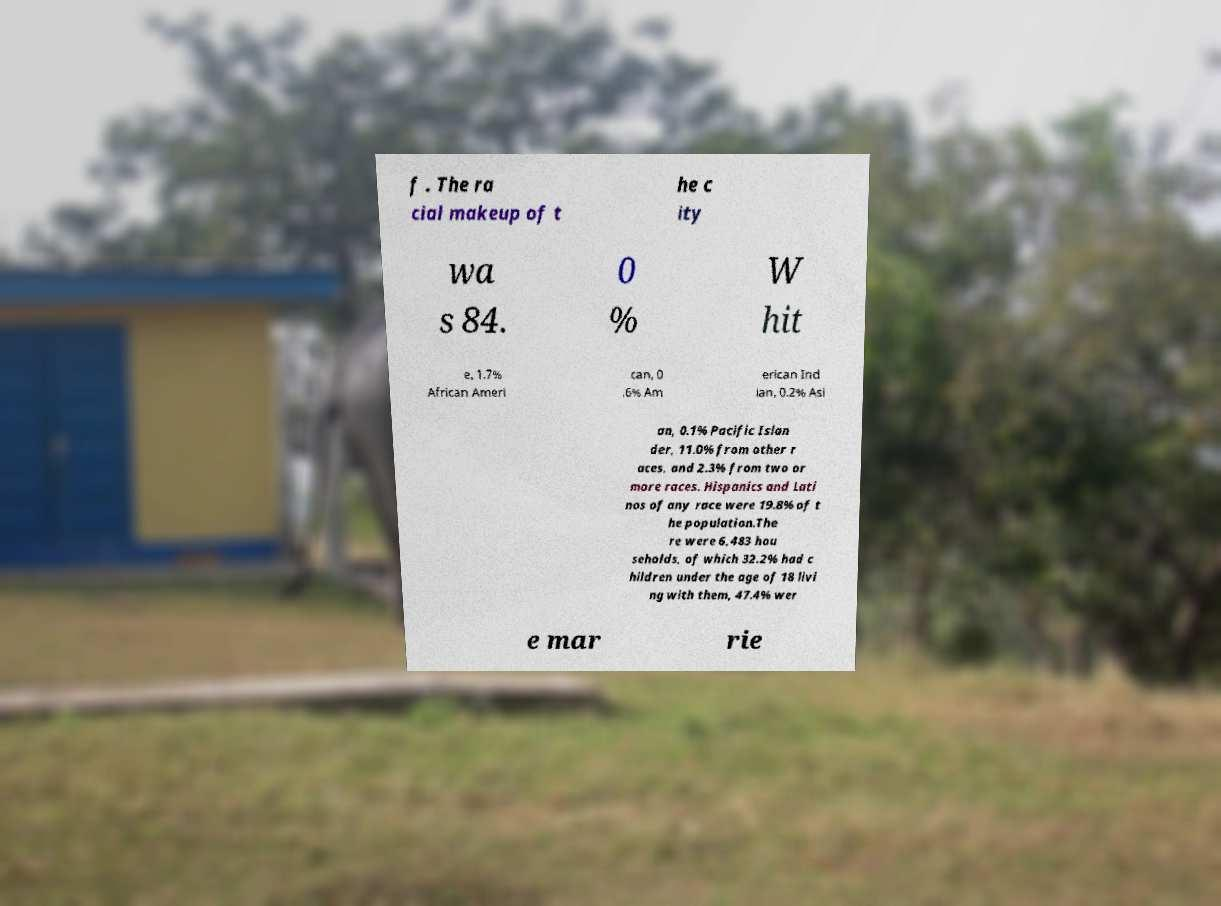What messages or text are displayed in this image? I need them in a readable, typed format. f . The ra cial makeup of t he c ity wa s 84. 0 % W hit e, 1.7% African Ameri can, 0 .6% Am erican Ind ian, 0.2% Asi an, 0.1% Pacific Islan der, 11.0% from other r aces, and 2.3% from two or more races. Hispanics and Lati nos of any race were 19.8% of t he population.The re were 6,483 hou seholds, of which 32.2% had c hildren under the age of 18 livi ng with them, 47.4% wer e mar rie 